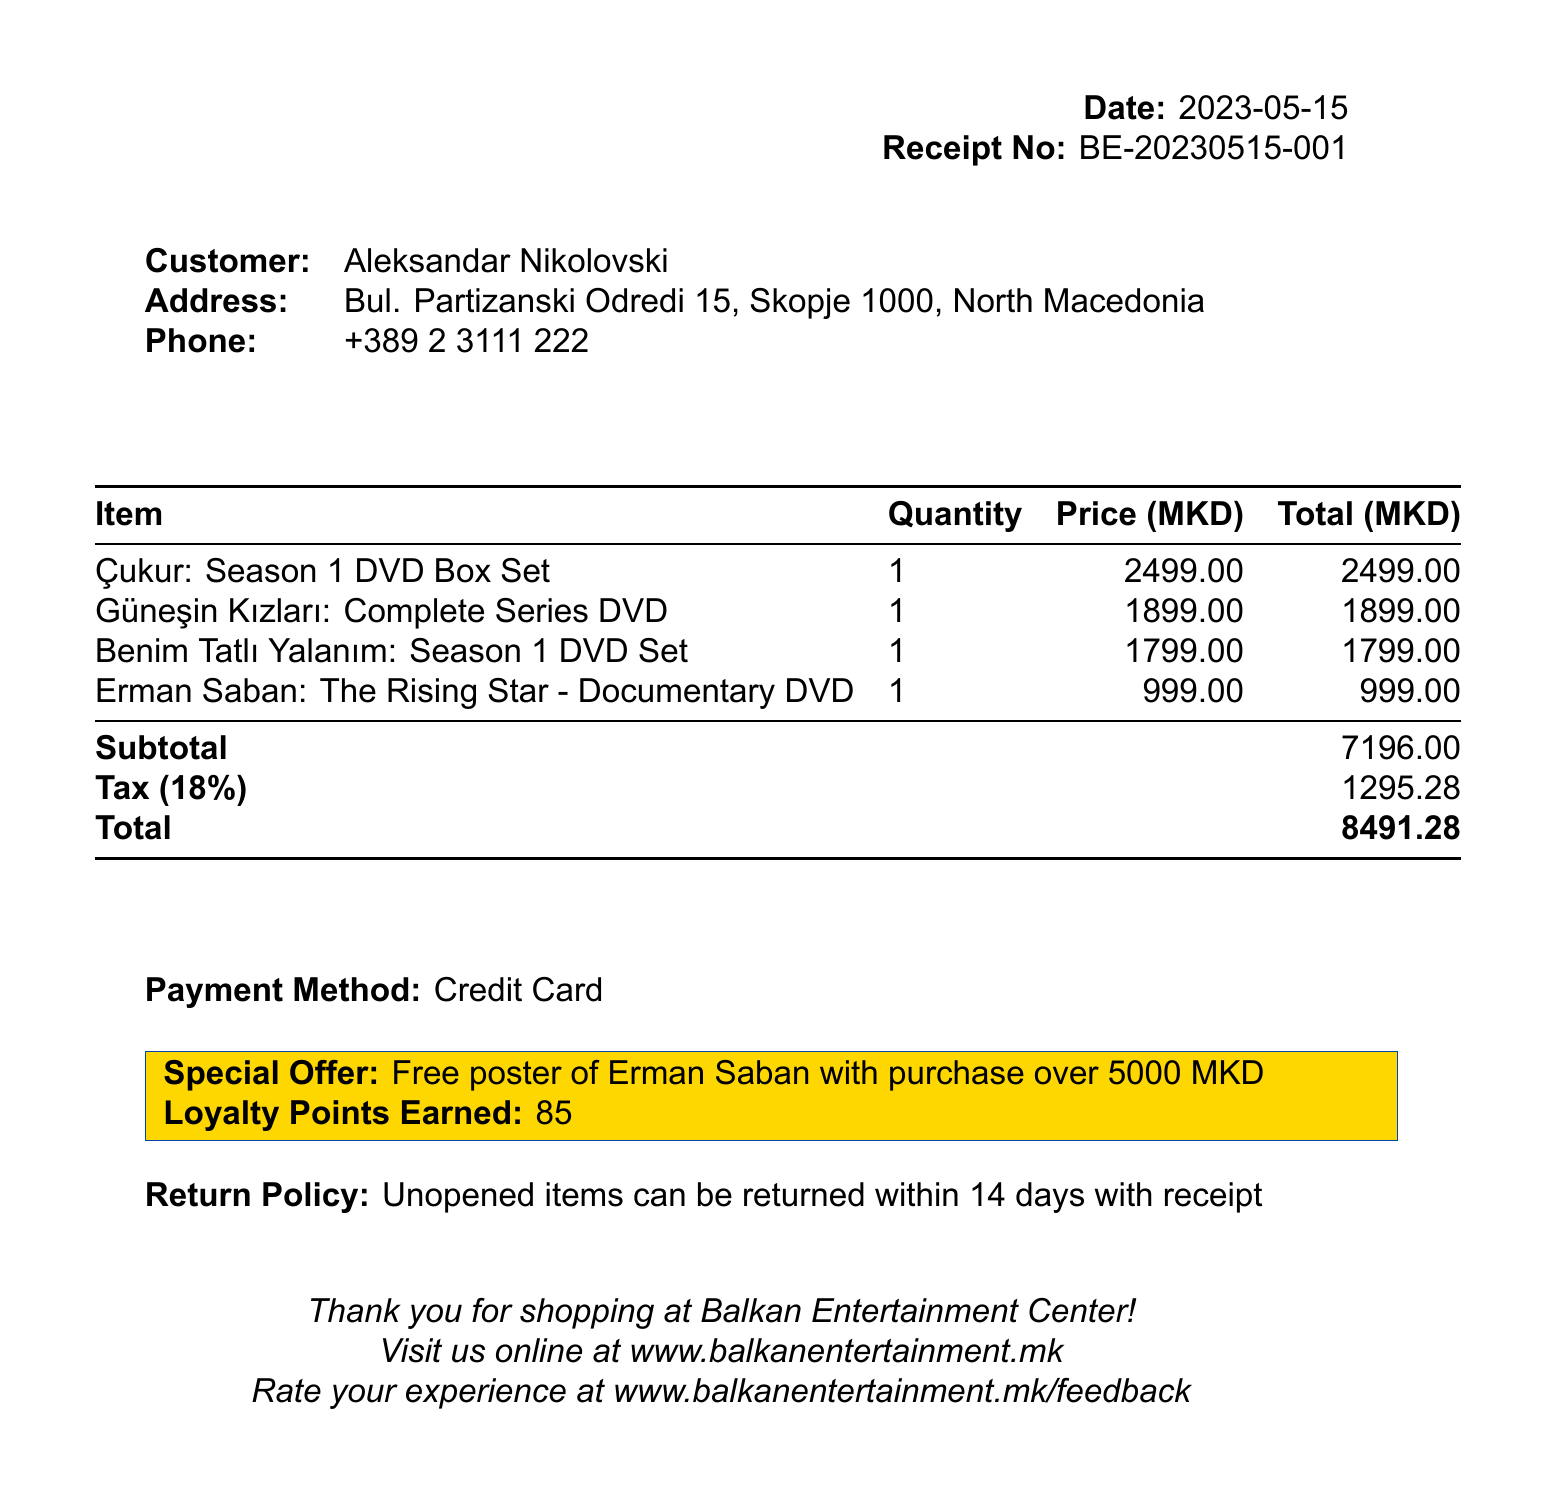what is the total amount spent? The total amount spent is provided at the end of the receipt after calculating the subtotal and tax.
Answer: 8491.28 what is the name of the store? The name of the store is listed at the top of the receipt.
Answer: Balkan Entertainment Center who is the customer? The name of the customer is specified under the customer information section.
Answer: Aleksandar Nikolovski when was the purchase made? The date of the purchase is noted prominently on the receipt.
Answer: 2023-05-15 what items did the customer purchase? The receipt lists all items purchased in a table format.
Answer: Çukur: Season 1 DVD Box Set, Güneşin Kızları: Complete Series DVD Collection, Benim Tatlı Yalanım: Season 1 DVD Set, Erman Saban: The Rising Star - Documentary DVD what is the tax rate applied to the purchase? The tax rate is explicitly mentioned in the document.
Answer: 18% how many loyalty points were earned? The number of loyalty points earned is highlighted in a special section of the receipt.
Answer: 85 what is the return policy? The return policy is stated clearly near the end of the document.
Answer: Unopened items can be returned within 14 days with receipt what is the special offer mentioned? The special offer is noted in a colored box on the receipt.
Answer: Free poster of Erman Saban with purchase over 5000 MKD 